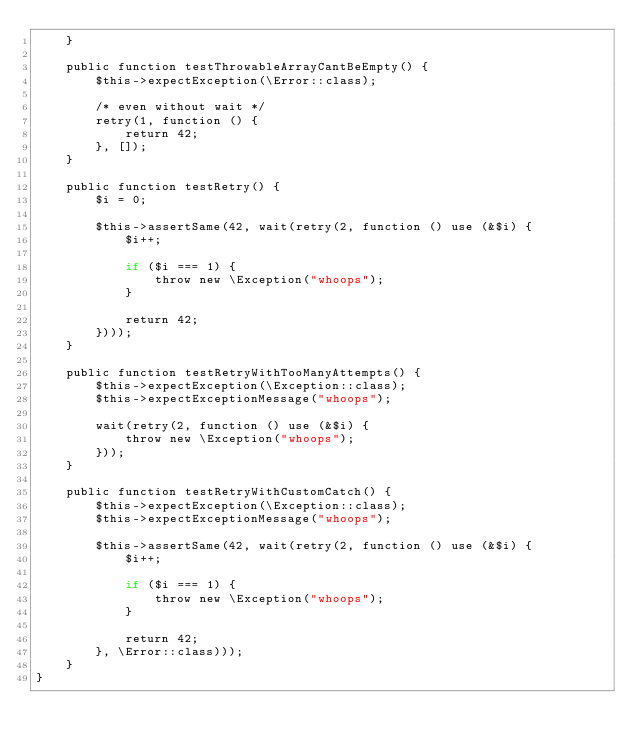Convert code to text. <code><loc_0><loc_0><loc_500><loc_500><_PHP_>    }

    public function testThrowableArrayCantBeEmpty() {
        $this->expectException(\Error::class);

        /* even without wait */
        retry(1, function () {
            return 42;
        }, []);
    }

    public function testRetry() {
        $i = 0;

        $this->assertSame(42, wait(retry(2, function () use (&$i) {
            $i++;

            if ($i === 1) {
                throw new \Exception("whoops");
            }

            return 42;
        })));
    }

    public function testRetryWithTooManyAttempts() {
        $this->expectException(\Exception::class);
        $this->expectExceptionMessage("whoops");

        wait(retry(2, function () use (&$i) {
            throw new \Exception("whoops");
        }));
    }

    public function testRetryWithCustomCatch() {
        $this->expectException(\Exception::class);
        $this->expectExceptionMessage("whoops");

        $this->assertSame(42, wait(retry(2, function () use (&$i) {
            $i++;

            if ($i === 1) {
                throw new \Exception("whoops");
            }

            return 42;
        }, \Error::class)));
    }
}
</code> 